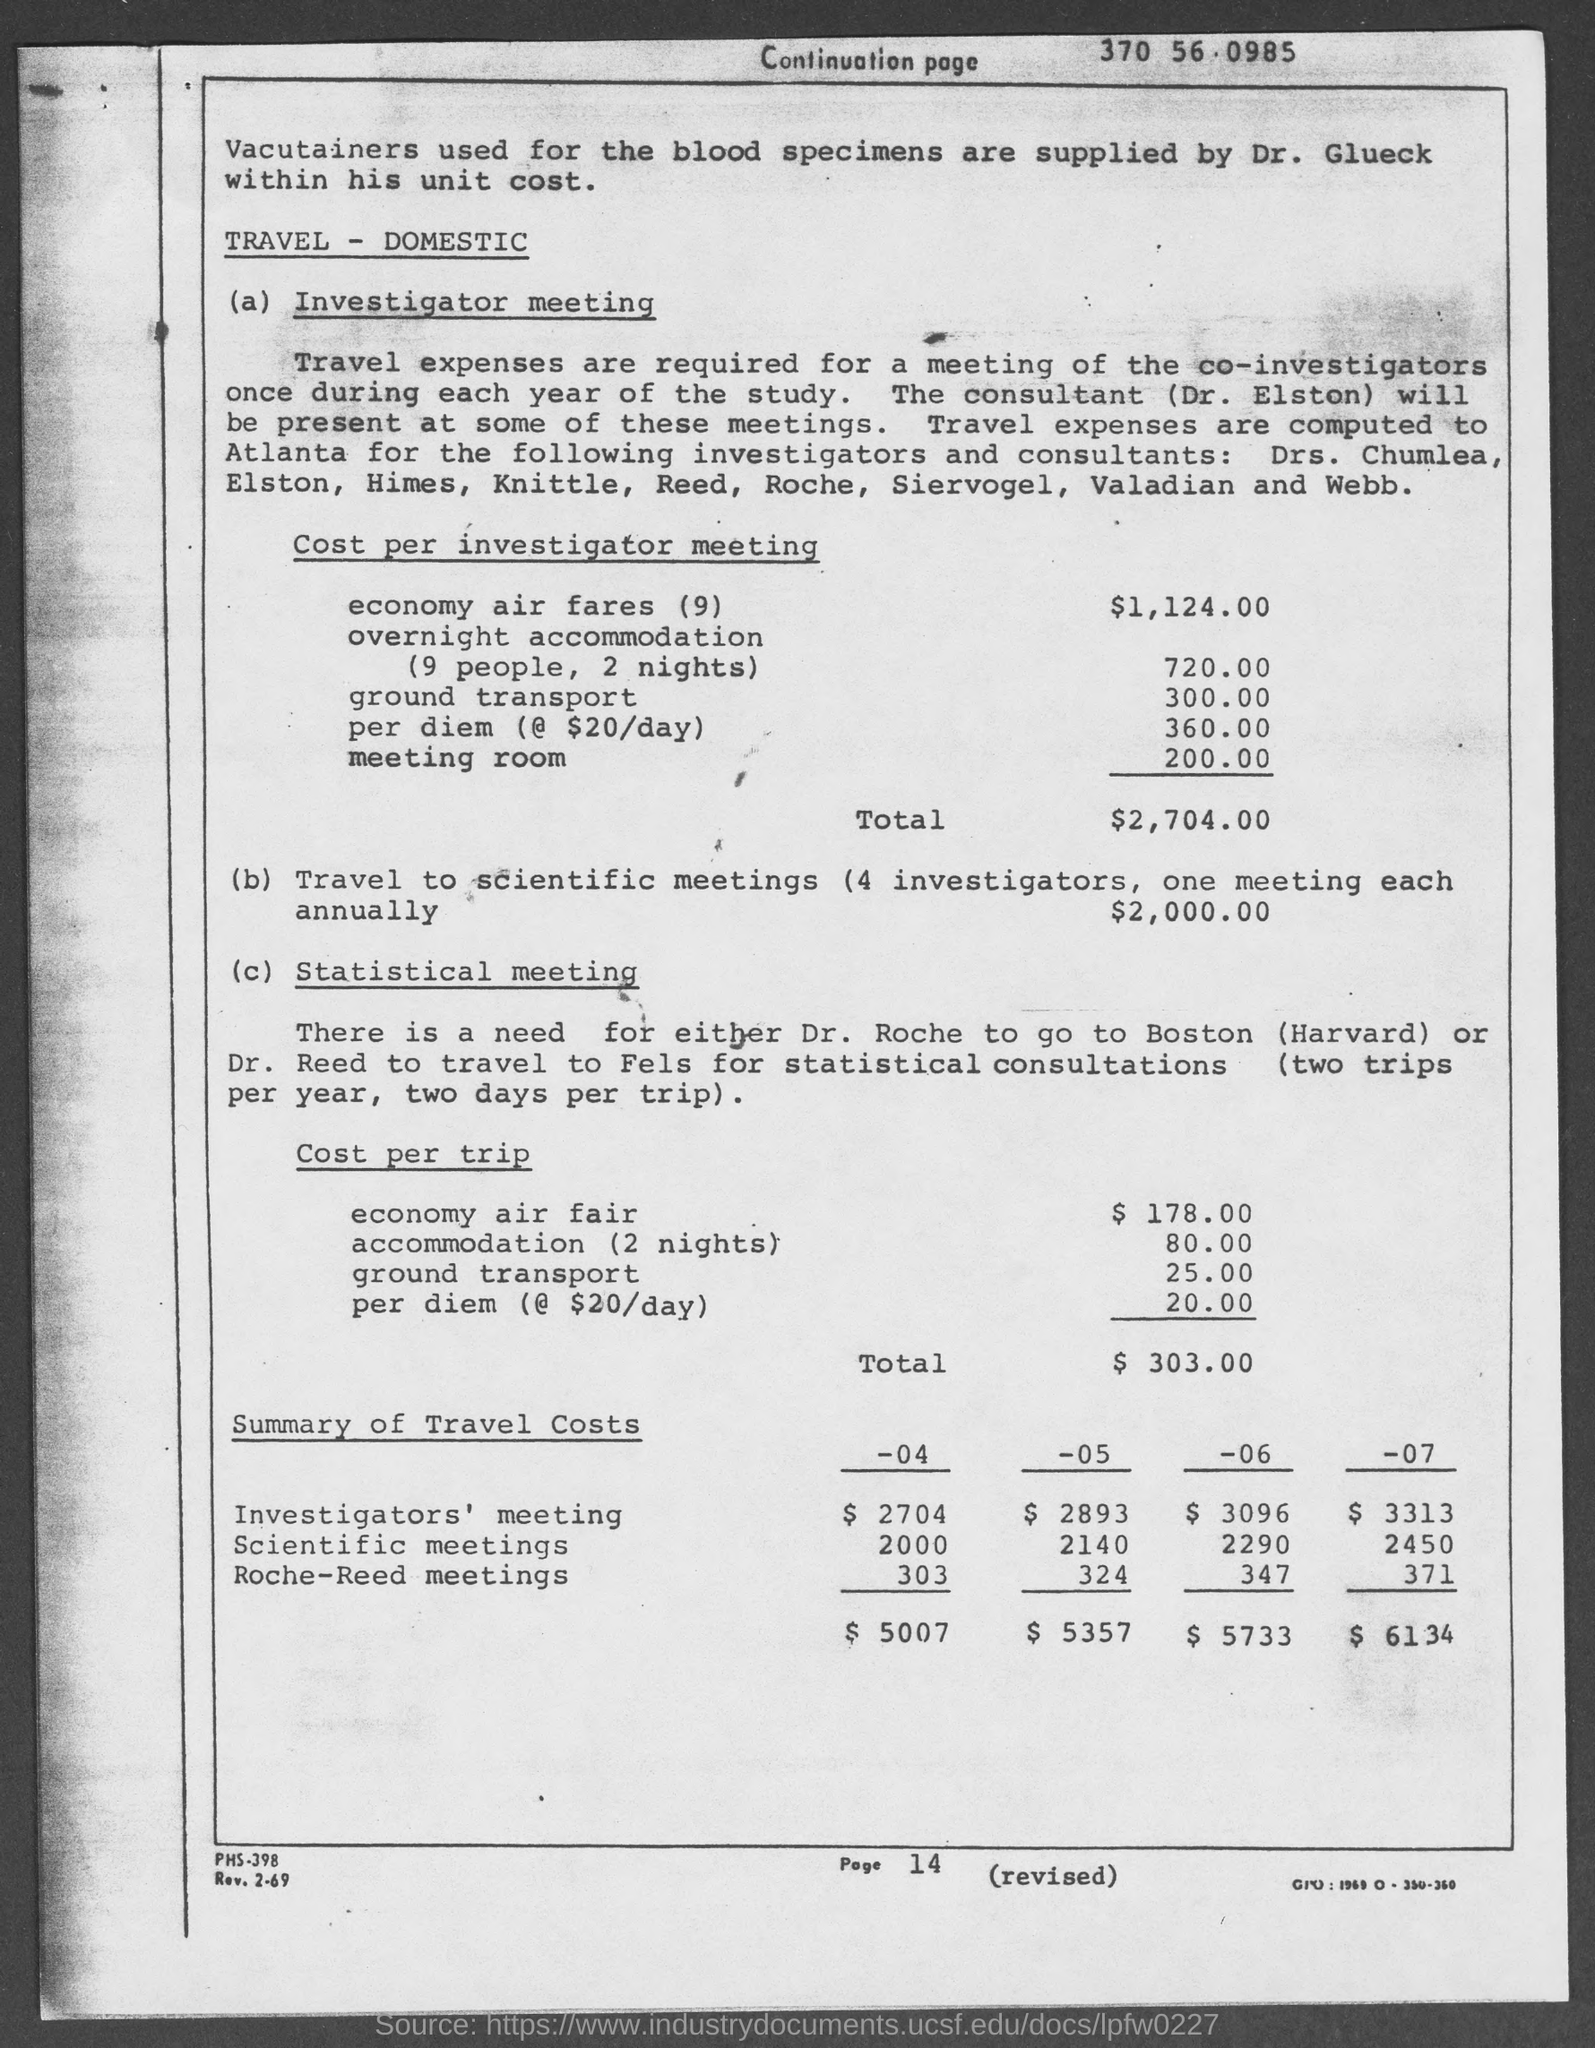Who is supplying vacutainers?
Your answer should be very brief. Dr. Glueck. Which consultant will be present at some of the meetings?
Provide a short and direct response. Dr. Elston. 